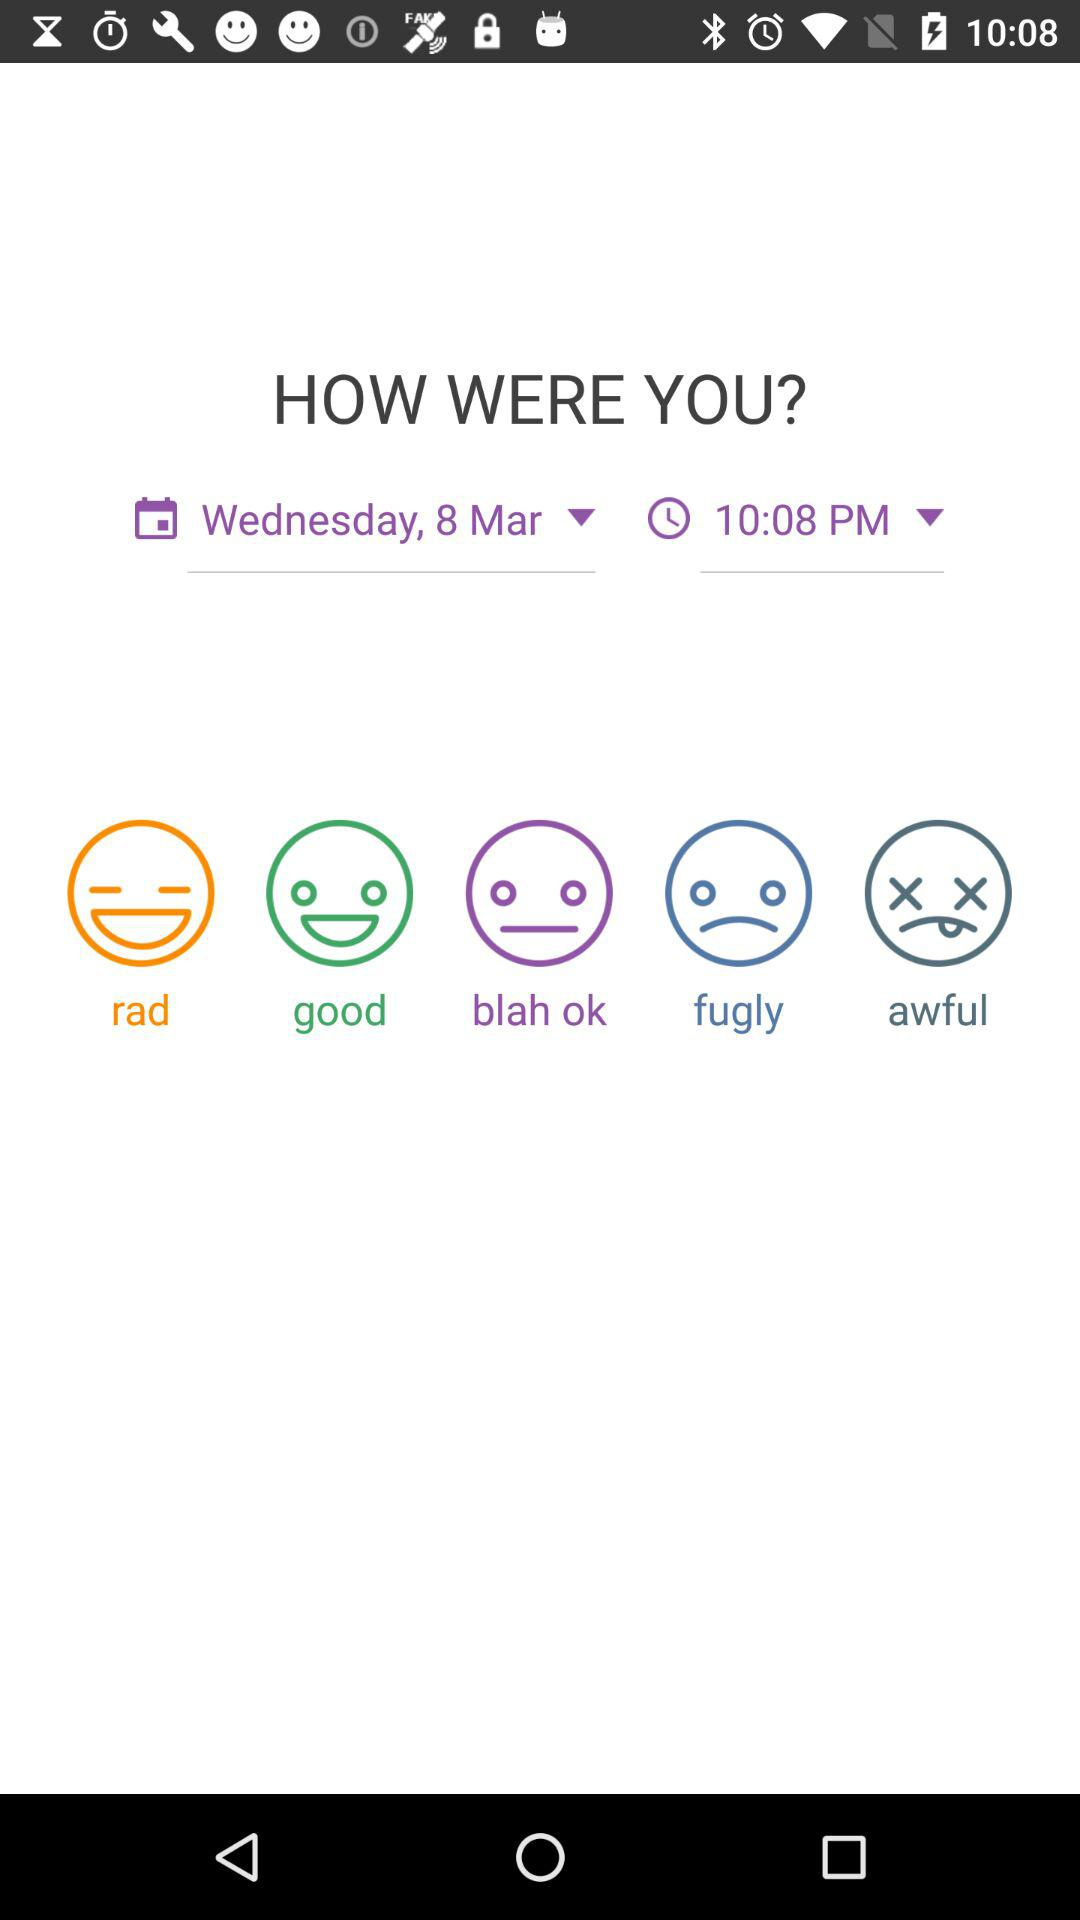What is the selected date and time? The selected date is Wednesday, March 8 and the time is 10:08 PM. 